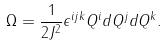Convert formula to latex. <formula><loc_0><loc_0><loc_500><loc_500>\Omega = \frac { 1 } { 2 J ^ { 2 } } \epsilon ^ { i j k } Q ^ { i } d Q ^ { j } d Q ^ { k } .</formula> 